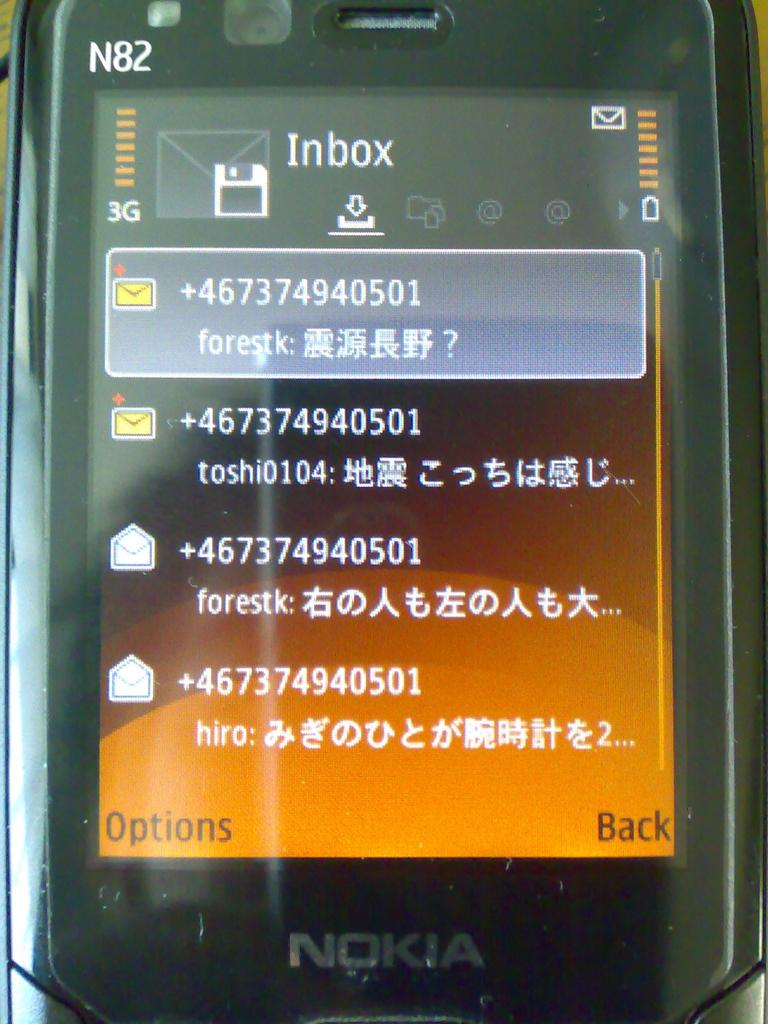<image>
Summarize the visual content of the image. a black nokia phone with the inbox of messages on the screen 